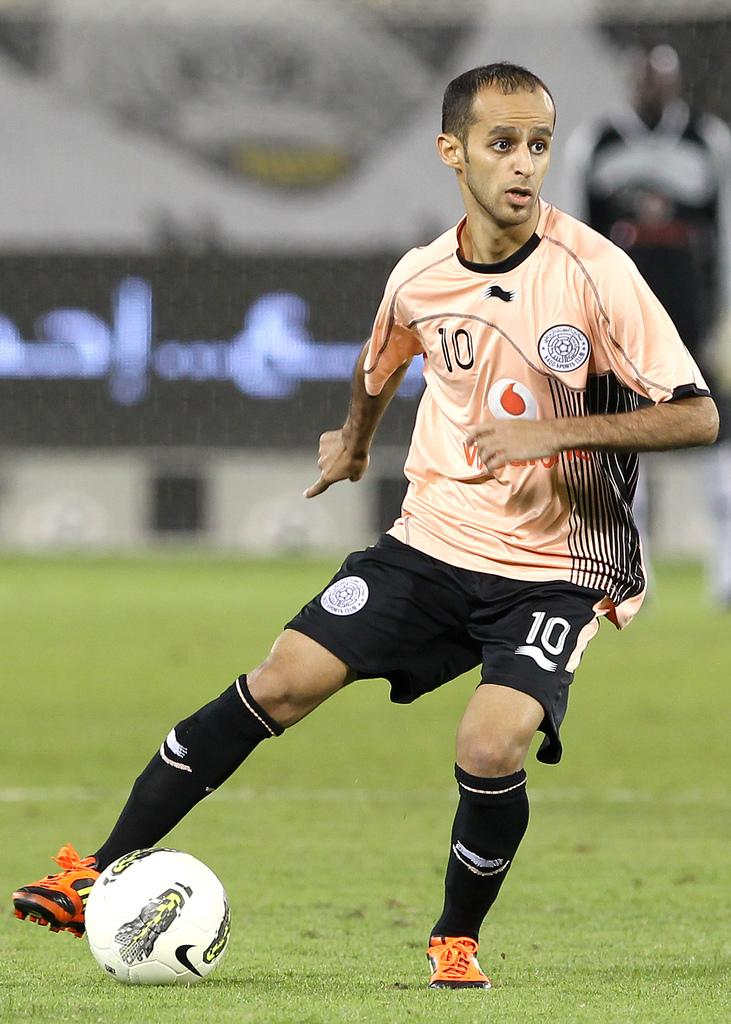Who is the main subject in the image? There is a man in the image. What is the man doing in the image? The man is playing football. What is the color of the field where the man is playing football? The field is green. What type of pain is the man experiencing while playing football in the image? There is no indication in the image that the man is experiencing any pain. 